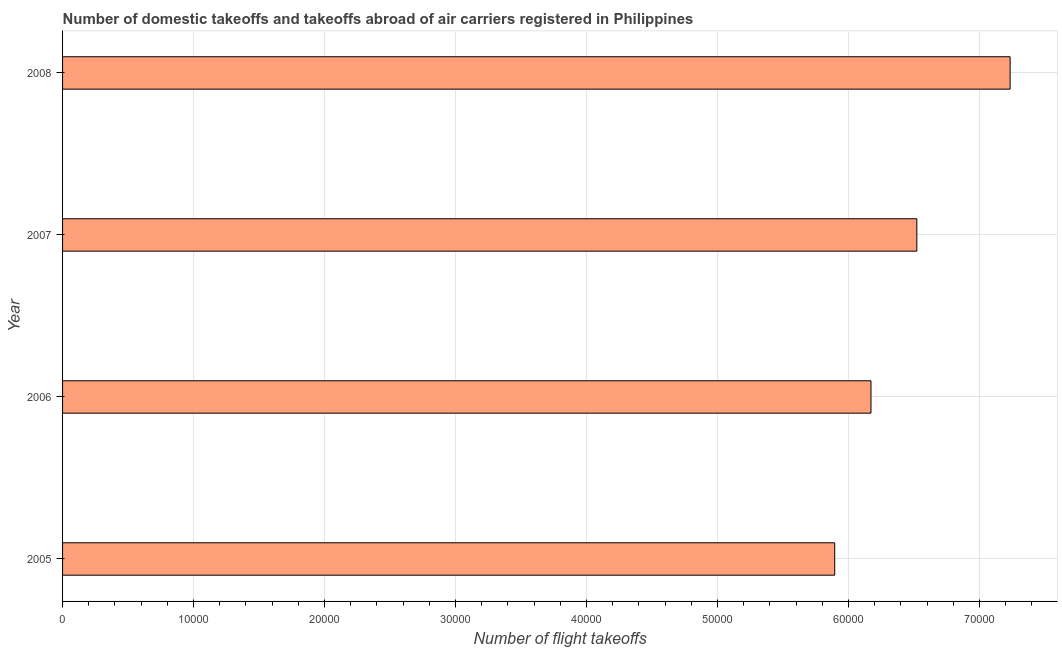Does the graph contain grids?
Your answer should be compact. Yes. What is the title of the graph?
Your answer should be very brief. Number of domestic takeoffs and takeoffs abroad of air carriers registered in Philippines. What is the label or title of the X-axis?
Keep it short and to the point. Number of flight takeoffs. What is the label or title of the Y-axis?
Your answer should be very brief. Year. What is the number of flight takeoffs in 2007?
Your answer should be compact. 6.52e+04. Across all years, what is the maximum number of flight takeoffs?
Give a very brief answer. 7.23e+04. Across all years, what is the minimum number of flight takeoffs?
Offer a very short reply. 5.89e+04. In which year was the number of flight takeoffs maximum?
Your answer should be compact. 2008. In which year was the number of flight takeoffs minimum?
Ensure brevity in your answer.  2005. What is the sum of the number of flight takeoffs?
Offer a very short reply. 2.58e+05. What is the difference between the number of flight takeoffs in 2007 and 2008?
Your answer should be very brief. -7121. What is the average number of flight takeoffs per year?
Ensure brevity in your answer.  6.46e+04. What is the median number of flight takeoffs?
Keep it short and to the point. 6.35e+04. What is the ratio of the number of flight takeoffs in 2007 to that in 2008?
Make the answer very short. 0.9. What is the difference between the highest and the second highest number of flight takeoffs?
Your answer should be very brief. 7121. Is the sum of the number of flight takeoffs in 2006 and 2007 greater than the maximum number of flight takeoffs across all years?
Offer a very short reply. Yes. What is the difference between the highest and the lowest number of flight takeoffs?
Ensure brevity in your answer.  1.34e+04. How many bars are there?
Your answer should be compact. 4. How many years are there in the graph?
Your answer should be very brief. 4. What is the difference between two consecutive major ticks on the X-axis?
Your answer should be very brief. 10000. Are the values on the major ticks of X-axis written in scientific E-notation?
Your response must be concise. No. What is the Number of flight takeoffs of 2005?
Your answer should be compact. 5.89e+04. What is the Number of flight takeoffs of 2006?
Offer a very short reply. 6.17e+04. What is the Number of flight takeoffs in 2007?
Keep it short and to the point. 6.52e+04. What is the Number of flight takeoffs of 2008?
Offer a very short reply. 7.23e+04. What is the difference between the Number of flight takeoffs in 2005 and 2006?
Offer a terse response. -2768. What is the difference between the Number of flight takeoffs in 2005 and 2007?
Your answer should be compact. -6268. What is the difference between the Number of flight takeoffs in 2005 and 2008?
Ensure brevity in your answer.  -1.34e+04. What is the difference between the Number of flight takeoffs in 2006 and 2007?
Your answer should be compact. -3500. What is the difference between the Number of flight takeoffs in 2006 and 2008?
Provide a succinct answer. -1.06e+04. What is the difference between the Number of flight takeoffs in 2007 and 2008?
Your answer should be compact. -7121. What is the ratio of the Number of flight takeoffs in 2005 to that in 2006?
Ensure brevity in your answer.  0.95. What is the ratio of the Number of flight takeoffs in 2005 to that in 2007?
Ensure brevity in your answer.  0.9. What is the ratio of the Number of flight takeoffs in 2005 to that in 2008?
Ensure brevity in your answer.  0.81. What is the ratio of the Number of flight takeoffs in 2006 to that in 2007?
Offer a very short reply. 0.95. What is the ratio of the Number of flight takeoffs in 2006 to that in 2008?
Offer a terse response. 0.85. What is the ratio of the Number of flight takeoffs in 2007 to that in 2008?
Ensure brevity in your answer.  0.9. 